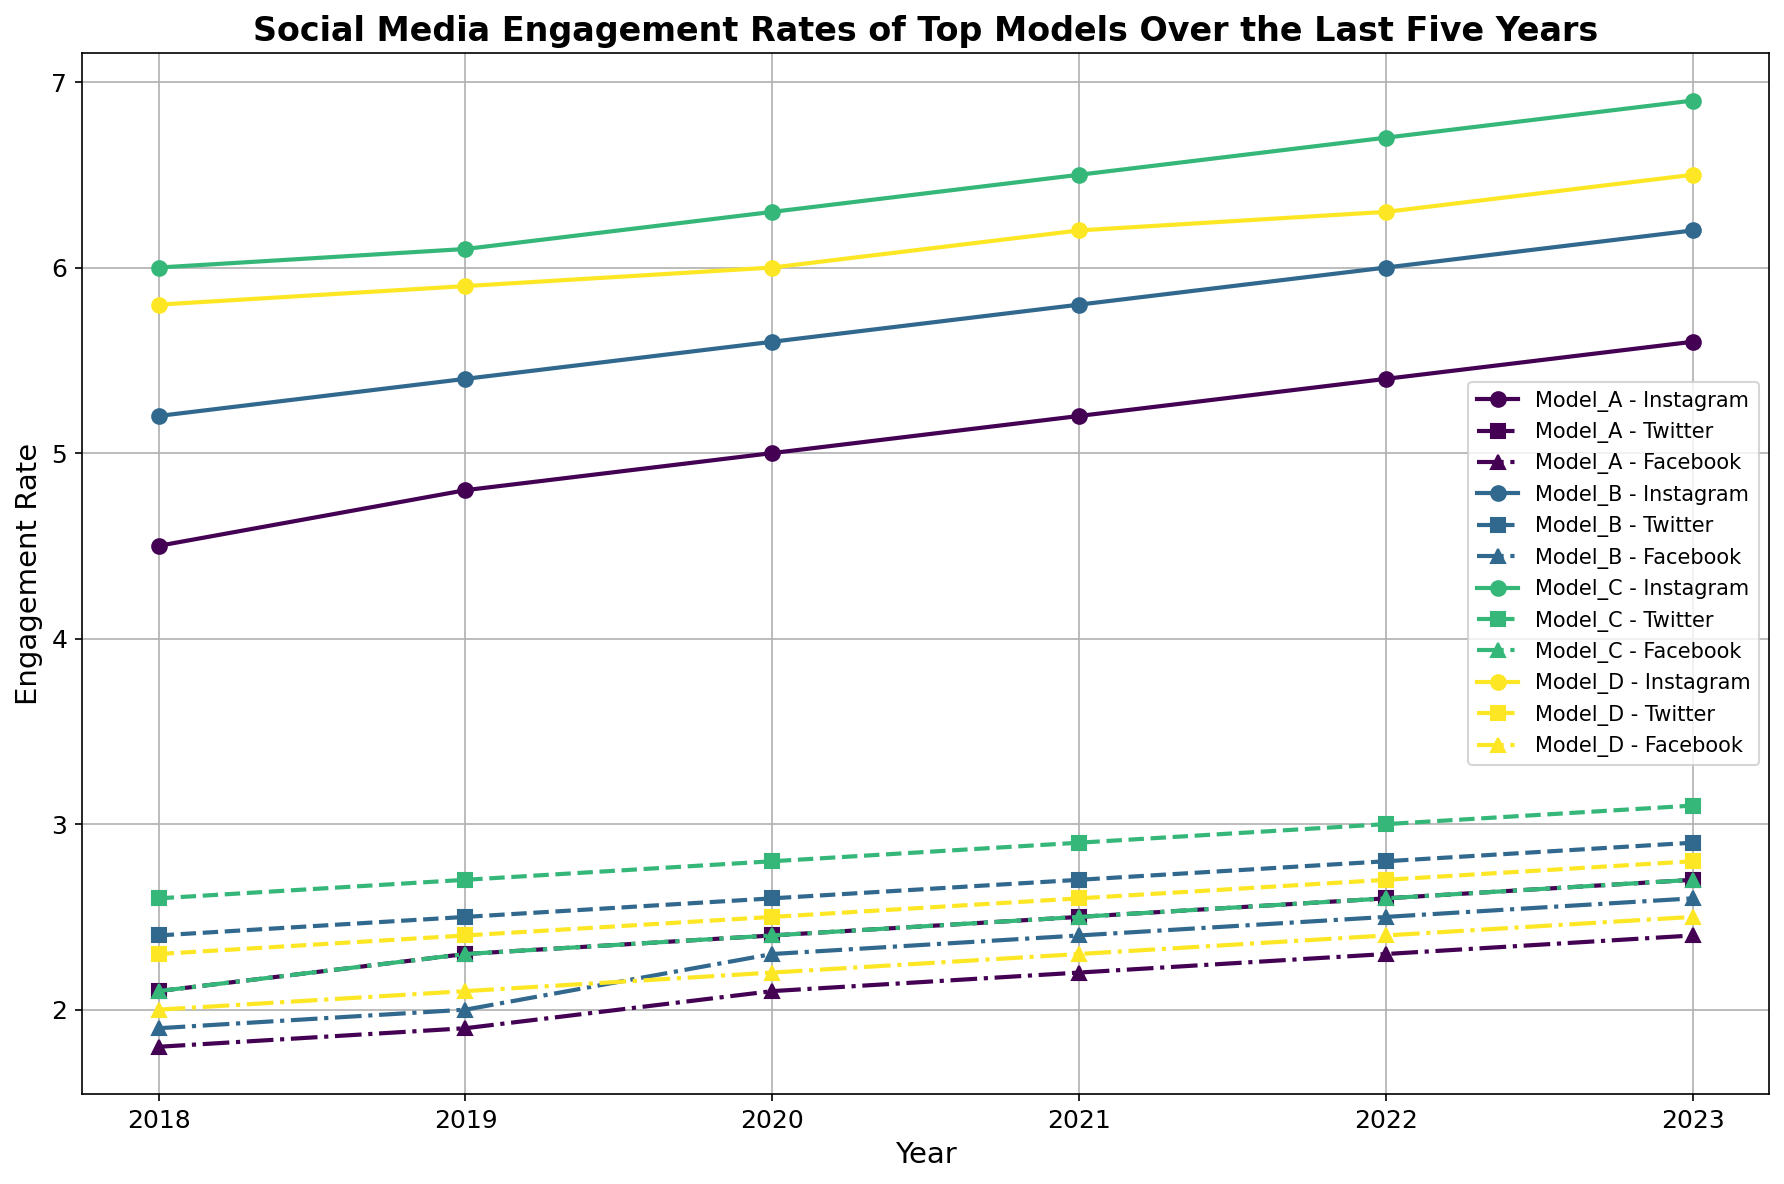What is the trend in Instagram engagement rates for Model_A from 2018 to 2023? To determine the trend, we observe the plotted line for Model_A on Instagram from 2018 to 2023. The engagement rates are increasing year by year (4.5 in 2018 to 5.6 in 2023).
Answer: Increasing trend Which model had the highest Facebook engagement rate in 2022? Looking at the Facebook engagement rates for all models in 2022, we find that Model_C had the highest rate at 2.6.
Answer: Model_C Compare the Twitter engagement rates for Model_B and Model_D in 2021. Which one was higher? The Twitter engagement rates for Model_B and Model_D in 2021 were plotted. Model_B had a rate of 2.7, while Model_D had a rate of 2.6. Therefore, Model_B’s rate was higher.
Answer: Model_B What was the difference in Instagram engagement rate between Model_C and Model_D in 2023? The Instagram engagement rates for Model_C and Model_D in 2023 were 6.9 and 6.5, respectively. Subtract Model_D's rate from Model_C's: 6.9 - 6.5 = 0.4.
Answer: 0.4 Which year did Model_D reach its peak Instagram engagement rate? Reviewing the Instagram engagement rates from 2018 to 2023 for Model_D, the highest rate was 6.5 in 2023.
Answer: 2023 How did Model_A's Twitter engagement rate change from 2018 to 2023? Examining Model_A's Twitter engagement rate from 2018 (2.1) to 2023 (2.7), it shows a gradual increase.
Answer: Increasing trend Among all models, who had the highest combined engagement rate (sum of Instagram, Twitter, and Facebook) in 2020? Sum engagement rates by combining Instagram, Twitter, and Facebook for all models in 2020:
Model_A: 5.0+2.4+2.1=9.5 
Model_B: 5.6+2.6+2.3=10.5 
Model_C: 6.3+2.8+2.4=11.5 
Model_D: 6.0+2.5+2.2=10.7.
Model_C had the highest combined engagement rate of 11.5.
Answer: Model_C Which model showed the greatest increase in Facebook engagement rate from 2021 to 2023? Comparing Facebook engagement rates from 2021 to 2023: 
Model_A: 2.2 to 2.4 (increase of 0.2) 
Model_B: 2.4 to 2.6 (increase of 0.2) 
Model_C: 2.5 to 2.7 (increase of 0.2) 
Model_D: 2.3 to 2.5 (increase of 0.2).
All models had the same increase, 0.2.
Answer: All models (0.2) Identify the year in which Model_B showed the largest year-over-year increase in Instagram engagement rate. Calculating the year-over-year increases for Model_B:
2018-2019: 5.4 - 5.2 = 0.2
2019-2020: 5.6 - 5.4 = 0.2
2020-2021: 5.8 - 5.6 = 0.2
2021-2022: 6.0 - 5.8 = 0.2
2022-2023: 6.2 - 6.0 = 0.2
The largest increase was consistently 0.2 across all years.
Answer: Identical increase In 2021, which model had the highest social media engagement rate on Twitter? Reviewing the plotted line for Twitter engagement rates in 2021, Model_C had the highest rate at 2.9.
Answer: Model_C 